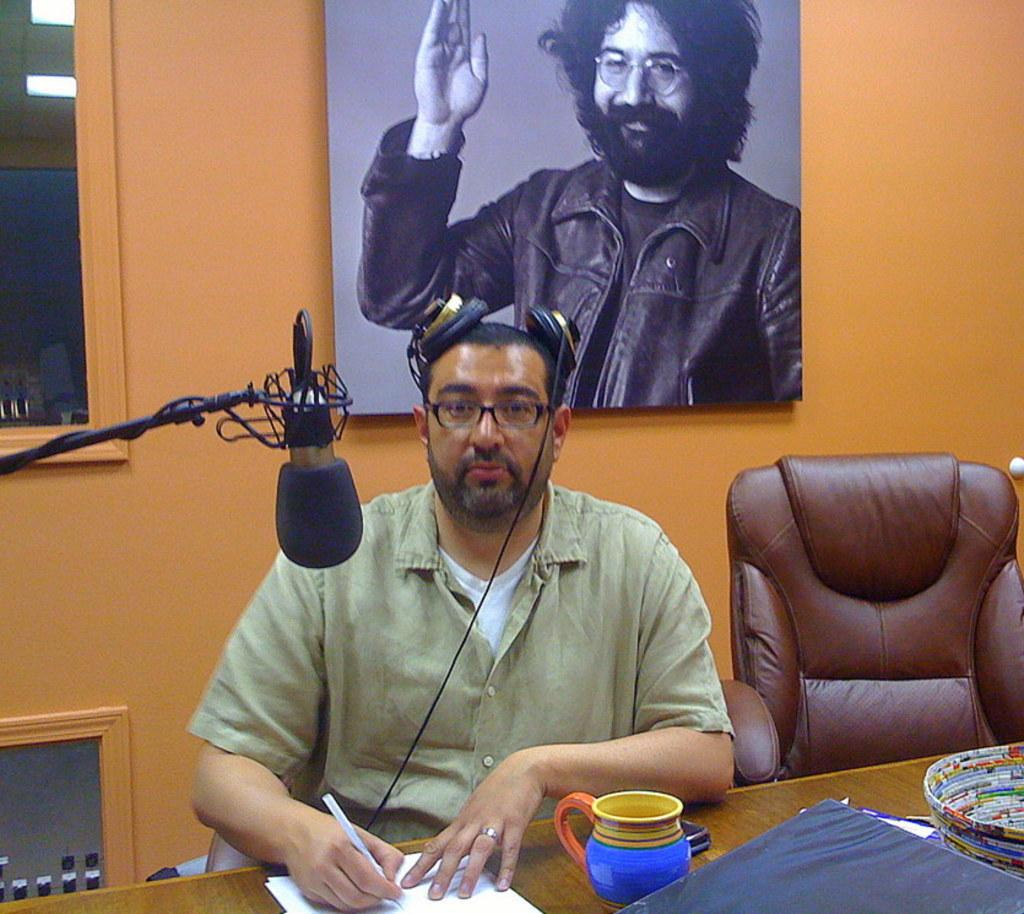What is the main subject of the image? There is a guy in the image. What is the guy doing in the image? The guy is sitting on a table. What is the guy wearing in the image? The guy is wearing headphones. Where are the headphones located when not being worn? The headphones are on the table. What object is placed in front of the guy? There is a microphone placed in front of the guy. What color is the wall in the background of the image? The background of the image includes an orange wall. Is there any other representation of the guy in the image? Yes, there is a portrait of the guy in the background. What type of scale is used to weigh the guy in the image? There is no scale present in the image, and the guy is not being weighed. 